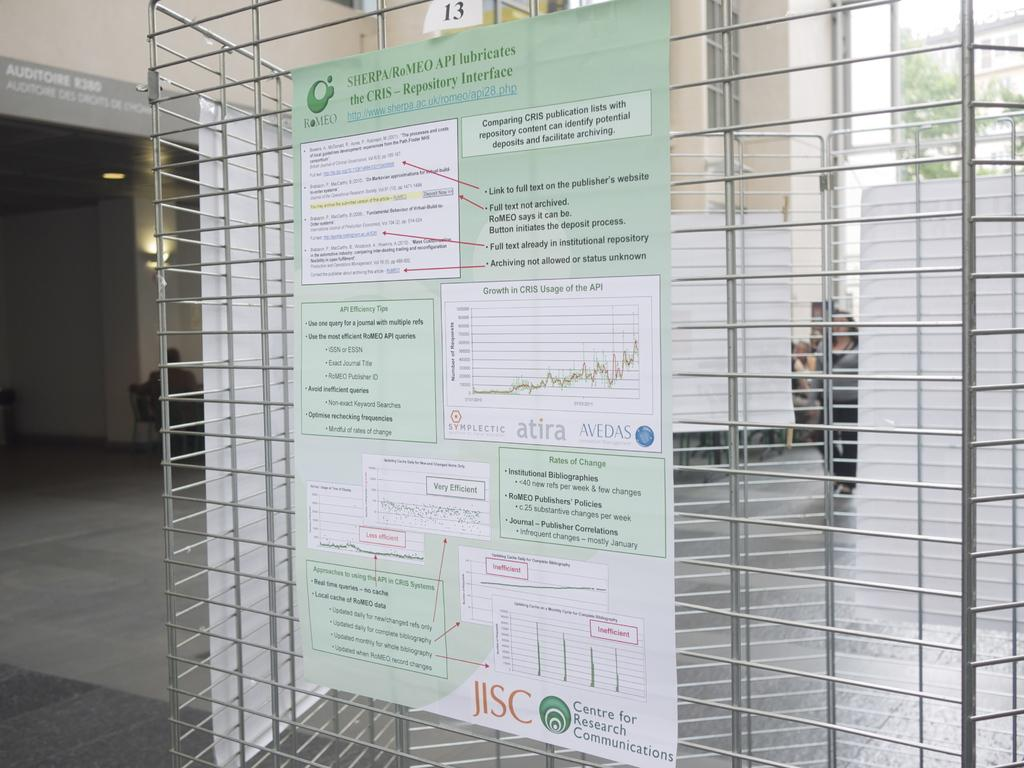<image>
Relay a brief, clear account of the picture shown. A research poster by JISC Centre for Research Communications 